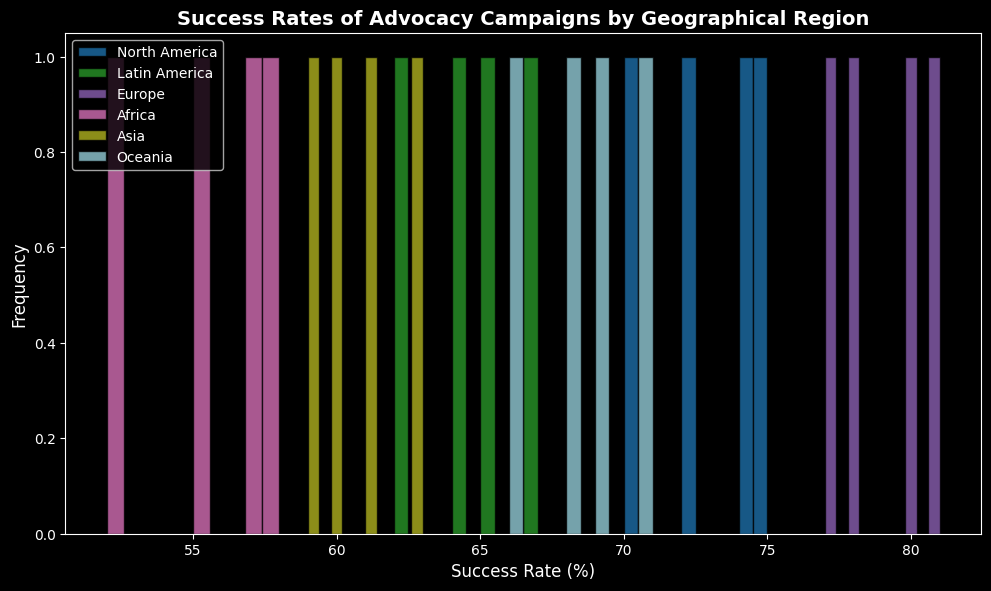Which region shows the highest frequency of success rates above 70%? By looking at the histogram, identify which region's bars mostly fall to the right of the 70% mark and have the highest height or frequency counts in that region.
Answer: Europe Do North America and Oceania have similar distributions of success rates? Compare the bars' positions and heights for both regions in the histogram. If they have similar heights and intervals, then their distributions are similar.
Answer: Yes Which region has the lowest frequency of success rates around 60%? Look at the histogram and determine which region has the least or no bars around the 60% success rate.
Answer: Africa Which two regions have the widest range of success rates? Observe the histograms and see which two regions have bars spread across a more extensive range (left to right on the x-axis).
Answer: Europe, North America What’s the average success rate for Latin America? Sum up the success rates for Latin America and divide by the number of data points. This involves (65 + 62 + 67 + 64) / 4 = 64.5
Answer: 64.5 Which region has the most consistent success rates (least variation)? Look at the histogram and see which region's bars are clustered closely together, indicating less variation.
Answer: Oceania How does the success rate distribution of Asia compare to Africa? Compare the histograms of Asia and Africa in terms of bar height distribution and range to determine differences and similarities.
Answer: Asia has a higher and narrower range than Africa Is the highest success rate in Europe greater than the highest success rate in North America? Identify the highest bar for Europe and compare its x-axis position to the highest bar for North America.
Answer: Yes What’s the median success rate range for Oceania? List the success rates for Oceania, sort them numerically, and find the middle value. If even, average the two middle numbers. The sorted values are 66, 69, 68, 71, the median is (68+69)/2 = 68.5
Answer: 68.5 